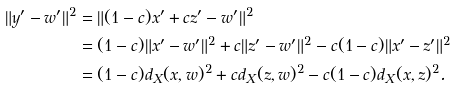Convert formula to latex. <formula><loc_0><loc_0><loc_500><loc_500>\| y ^ { \prime } - w ^ { \prime } \| ^ { 2 } & = \| ( 1 - c ) x ^ { \prime } + c z ^ { \prime } - w ^ { \prime } \| ^ { 2 } \\ & = ( 1 - c ) \| x ^ { \prime } - w ^ { \prime } \| ^ { 2 } + c \| z ^ { \prime } - w ^ { \prime } \| ^ { 2 } - c ( 1 - c ) \| x ^ { \prime } - z ^ { \prime } \| ^ { 2 } \\ & = ( 1 - c ) d _ { X } ( x , w ) ^ { 2 } + c d _ { X } ( z , w ) ^ { 2 } - c ( 1 - c ) d _ { X } ( x , z ) ^ { 2 } .</formula> 